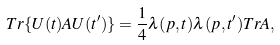<formula> <loc_0><loc_0><loc_500><loc_500>T r \{ U ( t ) A U ( t ^ { \prime } ) \} = \frac { 1 } { 4 } \lambda ( p , t ) \lambda ( p , t ^ { \prime } ) T r A ,</formula> 